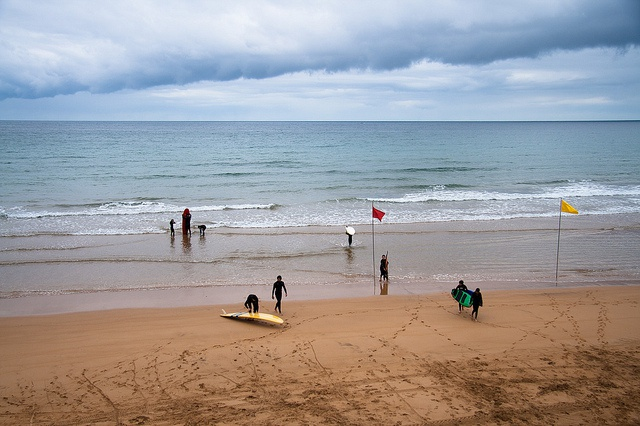Describe the objects in this image and their specific colors. I can see surfboard in lightblue, khaki, beige, tan, and gold tones, people in lightblue, black, gray, and tan tones, people in lightblue, black, darkgray, gray, and maroon tones, people in lightblue, black, gray, tan, and maroon tones, and people in lightblue, black, maroon, gray, and lightgray tones in this image. 